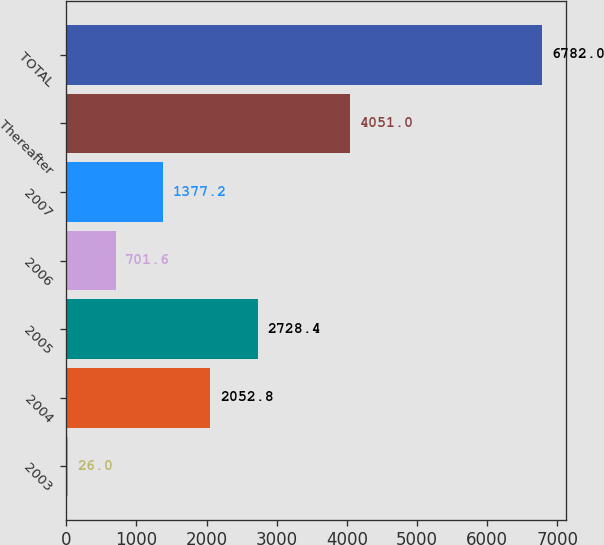Convert chart. <chart><loc_0><loc_0><loc_500><loc_500><bar_chart><fcel>2003<fcel>2004<fcel>2005<fcel>2006<fcel>2007<fcel>Thereafter<fcel>TOTAL<nl><fcel>26<fcel>2052.8<fcel>2728.4<fcel>701.6<fcel>1377.2<fcel>4051<fcel>6782<nl></chart> 